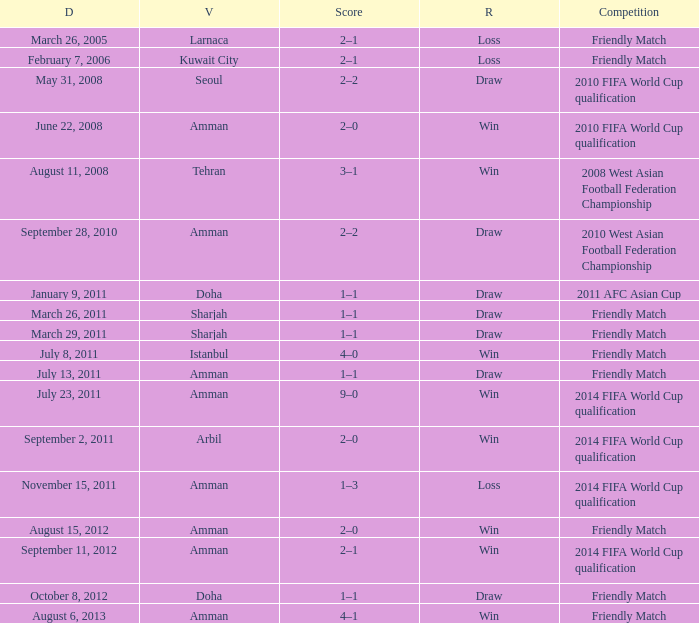During the loss on march 26, 2005, what was the venue where the match was played? Larnaca. 